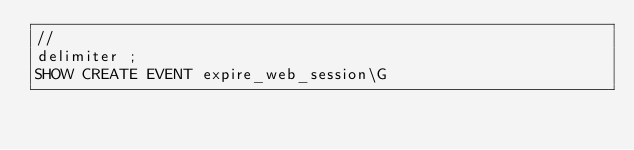Convert code to text. <code><loc_0><loc_0><loc_500><loc_500><_SQL_>//
delimiter ;
SHOW CREATE EVENT expire_web_session\G
</code> 